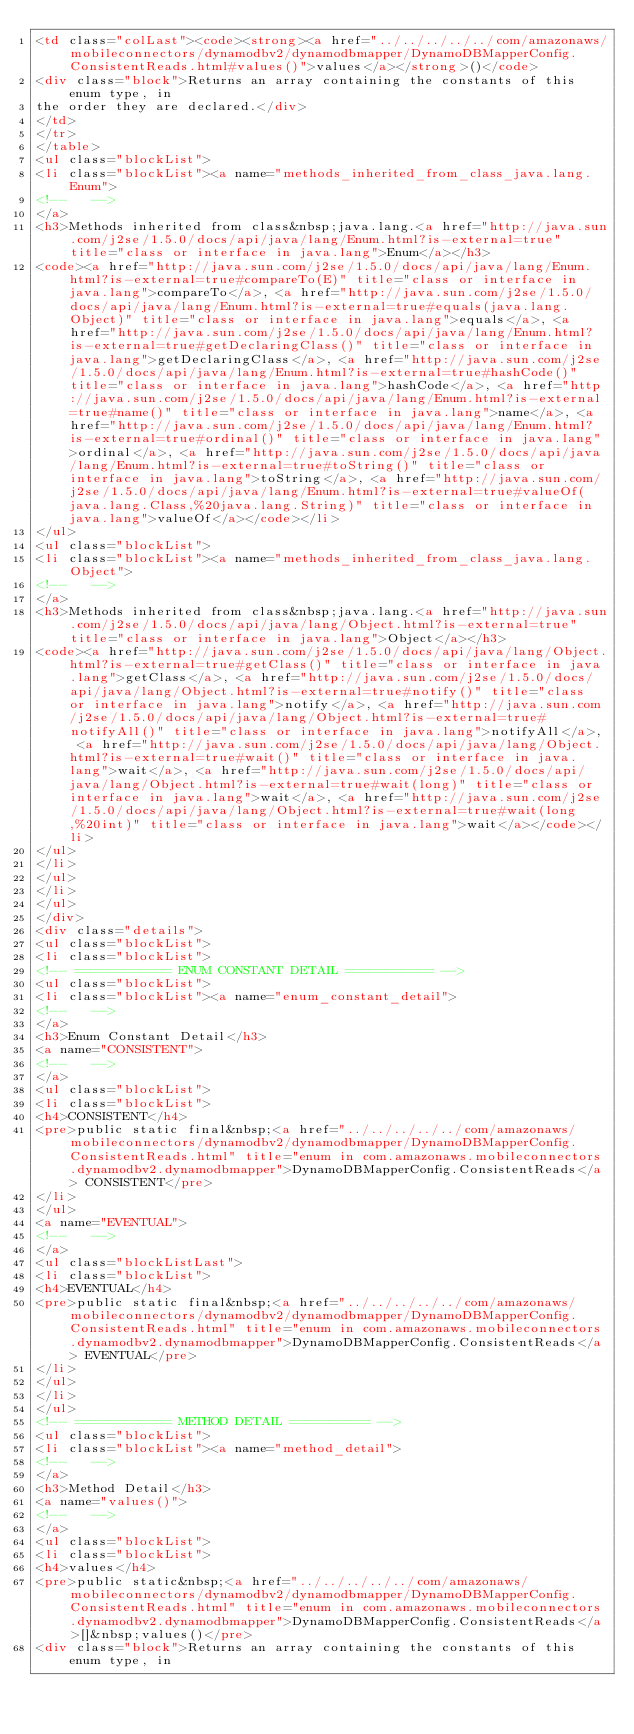<code> <loc_0><loc_0><loc_500><loc_500><_HTML_><td class="colLast"><code><strong><a href="../../../../../com/amazonaws/mobileconnectors/dynamodbv2/dynamodbmapper/DynamoDBMapperConfig.ConsistentReads.html#values()">values</a></strong>()</code>
<div class="block">Returns an array containing the constants of this enum type, in
the order they are declared.</div>
</td>
</tr>
</table>
<ul class="blockList">
<li class="blockList"><a name="methods_inherited_from_class_java.lang.Enum">
<!--   -->
</a>
<h3>Methods inherited from class&nbsp;java.lang.<a href="http://java.sun.com/j2se/1.5.0/docs/api/java/lang/Enum.html?is-external=true" title="class or interface in java.lang">Enum</a></h3>
<code><a href="http://java.sun.com/j2se/1.5.0/docs/api/java/lang/Enum.html?is-external=true#compareTo(E)" title="class or interface in java.lang">compareTo</a>, <a href="http://java.sun.com/j2se/1.5.0/docs/api/java/lang/Enum.html?is-external=true#equals(java.lang.Object)" title="class or interface in java.lang">equals</a>, <a href="http://java.sun.com/j2se/1.5.0/docs/api/java/lang/Enum.html?is-external=true#getDeclaringClass()" title="class or interface in java.lang">getDeclaringClass</a>, <a href="http://java.sun.com/j2se/1.5.0/docs/api/java/lang/Enum.html?is-external=true#hashCode()" title="class or interface in java.lang">hashCode</a>, <a href="http://java.sun.com/j2se/1.5.0/docs/api/java/lang/Enum.html?is-external=true#name()" title="class or interface in java.lang">name</a>, <a href="http://java.sun.com/j2se/1.5.0/docs/api/java/lang/Enum.html?is-external=true#ordinal()" title="class or interface in java.lang">ordinal</a>, <a href="http://java.sun.com/j2se/1.5.0/docs/api/java/lang/Enum.html?is-external=true#toString()" title="class or interface in java.lang">toString</a>, <a href="http://java.sun.com/j2se/1.5.0/docs/api/java/lang/Enum.html?is-external=true#valueOf(java.lang.Class,%20java.lang.String)" title="class or interface in java.lang">valueOf</a></code></li>
</ul>
<ul class="blockList">
<li class="blockList"><a name="methods_inherited_from_class_java.lang.Object">
<!--   -->
</a>
<h3>Methods inherited from class&nbsp;java.lang.<a href="http://java.sun.com/j2se/1.5.0/docs/api/java/lang/Object.html?is-external=true" title="class or interface in java.lang">Object</a></h3>
<code><a href="http://java.sun.com/j2se/1.5.0/docs/api/java/lang/Object.html?is-external=true#getClass()" title="class or interface in java.lang">getClass</a>, <a href="http://java.sun.com/j2se/1.5.0/docs/api/java/lang/Object.html?is-external=true#notify()" title="class or interface in java.lang">notify</a>, <a href="http://java.sun.com/j2se/1.5.0/docs/api/java/lang/Object.html?is-external=true#notifyAll()" title="class or interface in java.lang">notifyAll</a>, <a href="http://java.sun.com/j2se/1.5.0/docs/api/java/lang/Object.html?is-external=true#wait()" title="class or interface in java.lang">wait</a>, <a href="http://java.sun.com/j2se/1.5.0/docs/api/java/lang/Object.html?is-external=true#wait(long)" title="class or interface in java.lang">wait</a>, <a href="http://java.sun.com/j2se/1.5.0/docs/api/java/lang/Object.html?is-external=true#wait(long,%20int)" title="class or interface in java.lang">wait</a></code></li>
</ul>
</li>
</ul>
</li>
</ul>
</div>
<div class="details">
<ul class="blockList">
<li class="blockList">
<!-- ============ ENUM CONSTANT DETAIL =========== -->
<ul class="blockList">
<li class="blockList"><a name="enum_constant_detail">
<!--   -->
</a>
<h3>Enum Constant Detail</h3>
<a name="CONSISTENT">
<!--   -->
</a>
<ul class="blockList">
<li class="blockList">
<h4>CONSISTENT</h4>
<pre>public static final&nbsp;<a href="../../../../../com/amazonaws/mobileconnectors/dynamodbv2/dynamodbmapper/DynamoDBMapperConfig.ConsistentReads.html" title="enum in com.amazonaws.mobileconnectors.dynamodbv2.dynamodbmapper">DynamoDBMapperConfig.ConsistentReads</a> CONSISTENT</pre>
</li>
</ul>
<a name="EVENTUAL">
<!--   -->
</a>
<ul class="blockListLast">
<li class="blockList">
<h4>EVENTUAL</h4>
<pre>public static final&nbsp;<a href="../../../../../com/amazonaws/mobileconnectors/dynamodbv2/dynamodbmapper/DynamoDBMapperConfig.ConsistentReads.html" title="enum in com.amazonaws.mobileconnectors.dynamodbv2.dynamodbmapper">DynamoDBMapperConfig.ConsistentReads</a> EVENTUAL</pre>
</li>
</ul>
</li>
</ul>
<!-- ============ METHOD DETAIL ========== -->
<ul class="blockList">
<li class="blockList"><a name="method_detail">
<!--   -->
</a>
<h3>Method Detail</h3>
<a name="values()">
<!--   -->
</a>
<ul class="blockList">
<li class="blockList">
<h4>values</h4>
<pre>public static&nbsp;<a href="../../../../../com/amazonaws/mobileconnectors/dynamodbv2/dynamodbmapper/DynamoDBMapperConfig.ConsistentReads.html" title="enum in com.amazonaws.mobileconnectors.dynamodbv2.dynamodbmapper">DynamoDBMapperConfig.ConsistentReads</a>[]&nbsp;values()</pre>
<div class="block">Returns an array containing the constants of this enum type, in</code> 